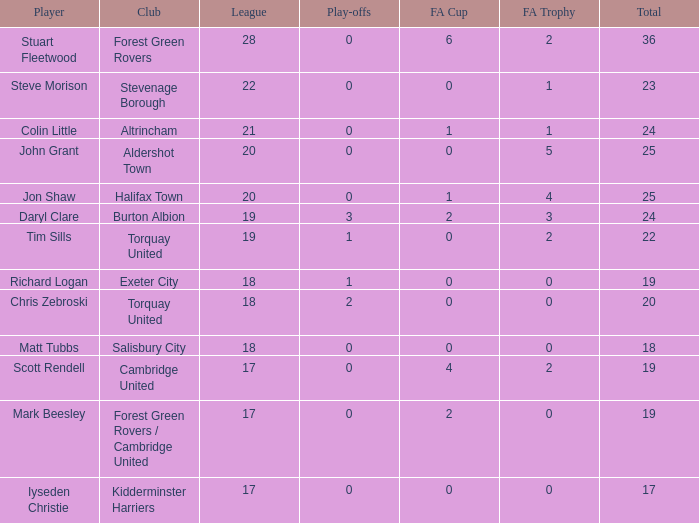Which of the lowest leagues had Aldershot town as a club when the play-offs number was less than 0? None. 